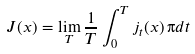<formula> <loc_0><loc_0><loc_500><loc_500>J ( x ) = \lim _ { T } \frac { 1 } { T } \int _ { 0 } ^ { T } j _ { t } ( x ) \, \i d t</formula> 